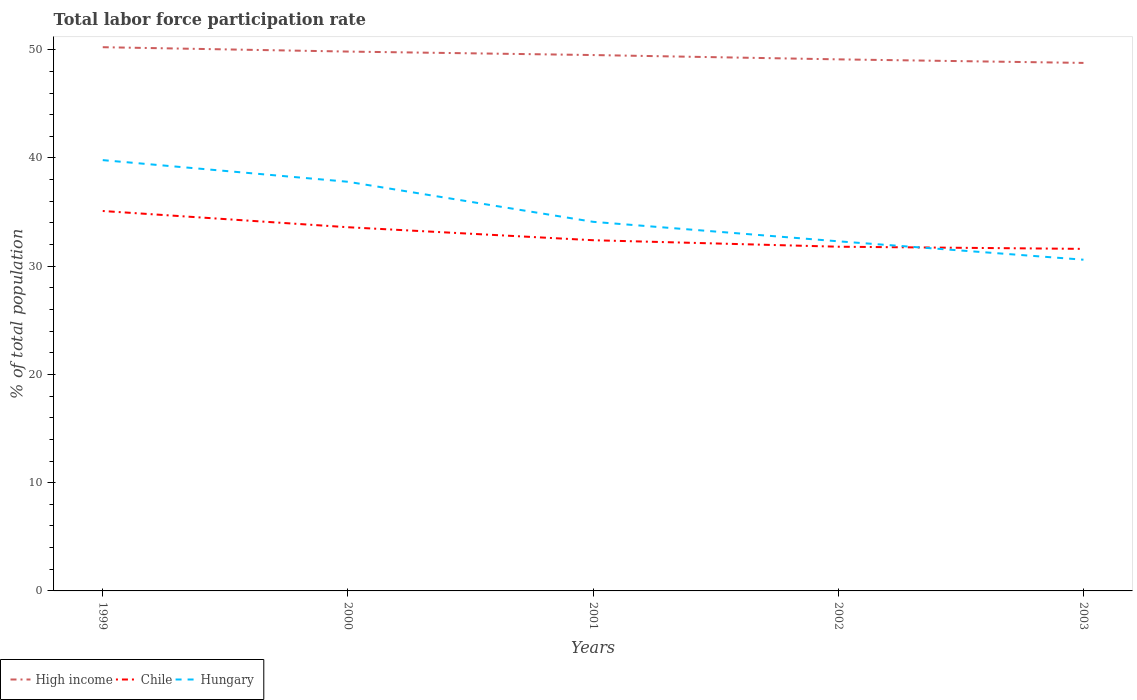How many different coloured lines are there?
Offer a very short reply. 3. Is the number of lines equal to the number of legend labels?
Keep it short and to the point. Yes. Across all years, what is the maximum total labor force participation rate in High income?
Your answer should be compact. 48.78. In which year was the total labor force participation rate in Chile maximum?
Provide a succinct answer. 2003. What is the total total labor force participation rate in Chile in the graph?
Offer a terse response. 3.5. What is the difference between the highest and the second highest total labor force participation rate in Hungary?
Offer a terse response. 9.2. What is the difference between the highest and the lowest total labor force participation rate in High income?
Keep it short and to the point. 3. What is the difference between two consecutive major ticks on the Y-axis?
Offer a terse response. 10. Are the values on the major ticks of Y-axis written in scientific E-notation?
Your answer should be very brief. No. Does the graph contain any zero values?
Offer a terse response. No. Does the graph contain grids?
Keep it short and to the point. No. Where does the legend appear in the graph?
Your answer should be very brief. Bottom left. How many legend labels are there?
Make the answer very short. 3. What is the title of the graph?
Give a very brief answer. Total labor force participation rate. Does "Zambia" appear as one of the legend labels in the graph?
Your response must be concise. No. What is the label or title of the X-axis?
Offer a terse response. Years. What is the label or title of the Y-axis?
Provide a succinct answer. % of total population. What is the % of total population in High income in 1999?
Your answer should be compact. 50.23. What is the % of total population of Chile in 1999?
Keep it short and to the point. 35.1. What is the % of total population in Hungary in 1999?
Provide a succinct answer. 39.8. What is the % of total population of High income in 2000?
Ensure brevity in your answer.  49.83. What is the % of total population in Chile in 2000?
Ensure brevity in your answer.  33.6. What is the % of total population in Hungary in 2000?
Your answer should be compact. 37.8. What is the % of total population of High income in 2001?
Give a very brief answer. 49.51. What is the % of total population in Chile in 2001?
Offer a terse response. 32.4. What is the % of total population in Hungary in 2001?
Offer a terse response. 34.1. What is the % of total population in High income in 2002?
Keep it short and to the point. 49.11. What is the % of total population of Chile in 2002?
Keep it short and to the point. 31.8. What is the % of total population in Hungary in 2002?
Provide a succinct answer. 32.3. What is the % of total population in High income in 2003?
Your answer should be very brief. 48.78. What is the % of total population in Chile in 2003?
Make the answer very short. 31.6. What is the % of total population in Hungary in 2003?
Ensure brevity in your answer.  30.6. Across all years, what is the maximum % of total population in High income?
Provide a succinct answer. 50.23. Across all years, what is the maximum % of total population of Chile?
Offer a terse response. 35.1. Across all years, what is the maximum % of total population in Hungary?
Give a very brief answer. 39.8. Across all years, what is the minimum % of total population of High income?
Ensure brevity in your answer.  48.78. Across all years, what is the minimum % of total population of Chile?
Give a very brief answer. 31.6. Across all years, what is the minimum % of total population of Hungary?
Your answer should be compact. 30.6. What is the total % of total population of High income in the graph?
Make the answer very short. 247.46. What is the total % of total population in Chile in the graph?
Make the answer very short. 164.5. What is the total % of total population in Hungary in the graph?
Make the answer very short. 174.6. What is the difference between the % of total population in High income in 1999 and that in 2000?
Provide a short and direct response. 0.4. What is the difference between the % of total population in Hungary in 1999 and that in 2000?
Provide a short and direct response. 2. What is the difference between the % of total population in High income in 1999 and that in 2001?
Give a very brief answer. 0.72. What is the difference between the % of total population of Chile in 1999 and that in 2001?
Keep it short and to the point. 2.7. What is the difference between the % of total population of Hungary in 1999 and that in 2001?
Provide a short and direct response. 5.7. What is the difference between the % of total population of High income in 1999 and that in 2002?
Offer a terse response. 1.12. What is the difference between the % of total population of Chile in 1999 and that in 2002?
Provide a succinct answer. 3.3. What is the difference between the % of total population in High income in 1999 and that in 2003?
Your response must be concise. 1.45. What is the difference between the % of total population in Chile in 1999 and that in 2003?
Your answer should be very brief. 3.5. What is the difference between the % of total population of Hungary in 1999 and that in 2003?
Give a very brief answer. 9.2. What is the difference between the % of total population in High income in 2000 and that in 2001?
Ensure brevity in your answer.  0.32. What is the difference between the % of total population in Chile in 2000 and that in 2001?
Provide a short and direct response. 1.2. What is the difference between the % of total population in High income in 2000 and that in 2002?
Give a very brief answer. 0.72. What is the difference between the % of total population of High income in 2000 and that in 2003?
Give a very brief answer. 1.05. What is the difference between the % of total population in Chile in 2000 and that in 2003?
Offer a very short reply. 2. What is the difference between the % of total population in Hungary in 2000 and that in 2003?
Make the answer very short. 7.2. What is the difference between the % of total population of High income in 2001 and that in 2002?
Make the answer very short. 0.4. What is the difference between the % of total population of High income in 2001 and that in 2003?
Your answer should be very brief. 0.73. What is the difference between the % of total population in High income in 2002 and that in 2003?
Offer a terse response. 0.33. What is the difference between the % of total population of Chile in 2002 and that in 2003?
Ensure brevity in your answer.  0.2. What is the difference between the % of total population in Hungary in 2002 and that in 2003?
Provide a short and direct response. 1.7. What is the difference between the % of total population in High income in 1999 and the % of total population in Chile in 2000?
Offer a terse response. 16.63. What is the difference between the % of total population of High income in 1999 and the % of total population of Hungary in 2000?
Offer a terse response. 12.43. What is the difference between the % of total population of High income in 1999 and the % of total population of Chile in 2001?
Your answer should be very brief. 17.83. What is the difference between the % of total population in High income in 1999 and the % of total population in Hungary in 2001?
Keep it short and to the point. 16.13. What is the difference between the % of total population of High income in 1999 and the % of total population of Chile in 2002?
Your response must be concise. 18.43. What is the difference between the % of total population of High income in 1999 and the % of total population of Hungary in 2002?
Provide a short and direct response. 17.93. What is the difference between the % of total population in High income in 1999 and the % of total population in Chile in 2003?
Your answer should be very brief. 18.63. What is the difference between the % of total population of High income in 1999 and the % of total population of Hungary in 2003?
Provide a succinct answer. 19.63. What is the difference between the % of total population in High income in 2000 and the % of total population in Chile in 2001?
Provide a succinct answer. 17.43. What is the difference between the % of total population of High income in 2000 and the % of total population of Hungary in 2001?
Make the answer very short. 15.73. What is the difference between the % of total population of Chile in 2000 and the % of total population of Hungary in 2001?
Your response must be concise. -0.5. What is the difference between the % of total population in High income in 2000 and the % of total population in Chile in 2002?
Give a very brief answer. 18.03. What is the difference between the % of total population in High income in 2000 and the % of total population in Hungary in 2002?
Give a very brief answer. 17.53. What is the difference between the % of total population in Chile in 2000 and the % of total population in Hungary in 2002?
Provide a short and direct response. 1.3. What is the difference between the % of total population of High income in 2000 and the % of total population of Chile in 2003?
Give a very brief answer. 18.23. What is the difference between the % of total population in High income in 2000 and the % of total population in Hungary in 2003?
Keep it short and to the point. 19.23. What is the difference between the % of total population of High income in 2001 and the % of total population of Chile in 2002?
Provide a succinct answer. 17.71. What is the difference between the % of total population of High income in 2001 and the % of total population of Hungary in 2002?
Offer a very short reply. 17.21. What is the difference between the % of total population of Chile in 2001 and the % of total population of Hungary in 2002?
Offer a very short reply. 0.1. What is the difference between the % of total population of High income in 2001 and the % of total population of Chile in 2003?
Give a very brief answer. 17.91. What is the difference between the % of total population in High income in 2001 and the % of total population in Hungary in 2003?
Provide a succinct answer. 18.91. What is the difference between the % of total population in High income in 2002 and the % of total population in Chile in 2003?
Your response must be concise. 17.51. What is the difference between the % of total population of High income in 2002 and the % of total population of Hungary in 2003?
Make the answer very short. 18.51. What is the average % of total population in High income per year?
Your answer should be very brief. 49.49. What is the average % of total population of Chile per year?
Your answer should be very brief. 32.9. What is the average % of total population of Hungary per year?
Your answer should be compact. 34.92. In the year 1999, what is the difference between the % of total population in High income and % of total population in Chile?
Make the answer very short. 15.13. In the year 1999, what is the difference between the % of total population in High income and % of total population in Hungary?
Provide a succinct answer. 10.43. In the year 2000, what is the difference between the % of total population of High income and % of total population of Chile?
Provide a short and direct response. 16.23. In the year 2000, what is the difference between the % of total population of High income and % of total population of Hungary?
Your answer should be very brief. 12.03. In the year 2000, what is the difference between the % of total population in Chile and % of total population in Hungary?
Your response must be concise. -4.2. In the year 2001, what is the difference between the % of total population of High income and % of total population of Chile?
Offer a terse response. 17.11. In the year 2001, what is the difference between the % of total population in High income and % of total population in Hungary?
Offer a very short reply. 15.41. In the year 2002, what is the difference between the % of total population in High income and % of total population in Chile?
Your answer should be compact. 17.31. In the year 2002, what is the difference between the % of total population of High income and % of total population of Hungary?
Provide a short and direct response. 16.81. In the year 2003, what is the difference between the % of total population of High income and % of total population of Chile?
Provide a succinct answer. 17.18. In the year 2003, what is the difference between the % of total population of High income and % of total population of Hungary?
Provide a succinct answer. 18.18. What is the ratio of the % of total population in High income in 1999 to that in 2000?
Offer a terse response. 1.01. What is the ratio of the % of total population of Chile in 1999 to that in 2000?
Give a very brief answer. 1.04. What is the ratio of the % of total population of Hungary in 1999 to that in 2000?
Offer a terse response. 1.05. What is the ratio of the % of total population of High income in 1999 to that in 2001?
Your response must be concise. 1.01. What is the ratio of the % of total population of Chile in 1999 to that in 2001?
Give a very brief answer. 1.08. What is the ratio of the % of total population of Hungary in 1999 to that in 2001?
Keep it short and to the point. 1.17. What is the ratio of the % of total population in High income in 1999 to that in 2002?
Make the answer very short. 1.02. What is the ratio of the % of total population in Chile in 1999 to that in 2002?
Provide a short and direct response. 1.1. What is the ratio of the % of total population in Hungary in 1999 to that in 2002?
Keep it short and to the point. 1.23. What is the ratio of the % of total population of High income in 1999 to that in 2003?
Ensure brevity in your answer.  1.03. What is the ratio of the % of total population of Chile in 1999 to that in 2003?
Your answer should be compact. 1.11. What is the ratio of the % of total population of Hungary in 1999 to that in 2003?
Make the answer very short. 1.3. What is the ratio of the % of total population in High income in 2000 to that in 2001?
Provide a short and direct response. 1.01. What is the ratio of the % of total population of Hungary in 2000 to that in 2001?
Provide a short and direct response. 1.11. What is the ratio of the % of total population of High income in 2000 to that in 2002?
Your answer should be compact. 1.01. What is the ratio of the % of total population in Chile in 2000 to that in 2002?
Your response must be concise. 1.06. What is the ratio of the % of total population in Hungary in 2000 to that in 2002?
Offer a terse response. 1.17. What is the ratio of the % of total population of High income in 2000 to that in 2003?
Your response must be concise. 1.02. What is the ratio of the % of total population in Chile in 2000 to that in 2003?
Your answer should be very brief. 1.06. What is the ratio of the % of total population in Hungary in 2000 to that in 2003?
Offer a very short reply. 1.24. What is the ratio of the % of total population of Chile in 2001 to that in 2002?
Make the answer very short. 1.02. What is the ratio of the % of total population of Hungary in 2001 to that in 2002?
Provide a succinct answer. 1.06. What is the ratio of the % of total population of High income in 2001 to that in 2003?
Your answer should be very brief. 1.01. What is the ratio of the % of total population of Chile in 2001 to that in 2003?
Offer a terse response. 1.03. What is the ratio of the % of total population in Hungary in 2001 to that in 2003?
Provide a succinct answer. 1.11. What is the ratio of the % of total population in High income in 2002 to that in 2003?
Provide a short and direct response. 1.01. What is the ratio of the % of total population in Chile in 2002 to that in 2003?
Make the answer very short. 1.01. What is the ratio of the % of total population in Hungary in 2002 to that in 2003?
Offer a terse response. 1.06. What is the difference between the highest and the second highest % of total population in High income?
Offer a very short reply. 0.4. What is the difference between the highest and the lowest % of total population in High income?
Provide a short and direct response. 1.45. What is the difference between the highest and the lowest % of total population of Chile?
Make the answer very short. 3.5. What is the difference between the highest and the lowest % of total population of Hungary?
Your response must be concise. 9.2. 